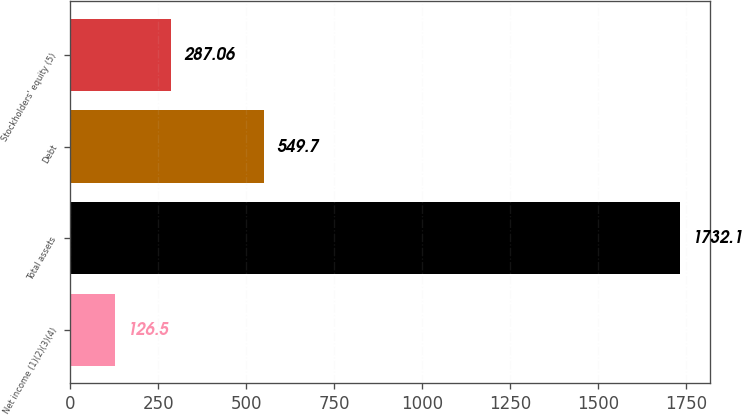Convert chart. <chart><loc_0><loc_0><loc_500><loc_500><bar_chart><fcel>Net income (1)(2)(3)(4)<fcel>Total assets<fcel>Debt<fcel>Stockholders' equity (5)<nl><fcel>126.5<fcel>1732.1<fcel>549.7<fcel>287.06<nl></chart> 